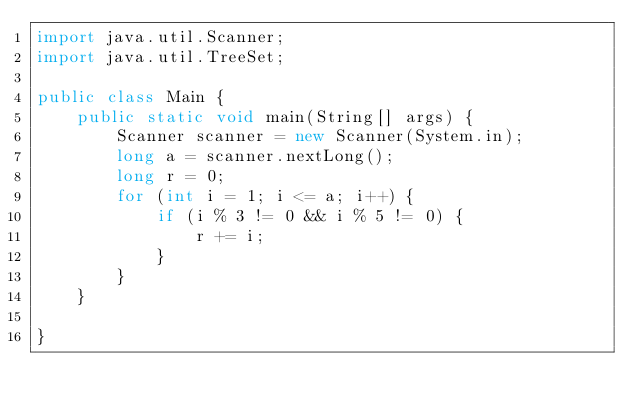<code> <loc_0><loc_0><loc_500><loc_500><_Java_>import java.util.Scanner;
import java.util.TreeSet;

public class Main {
    public static void main(String[] args) {
        Scanner scanner = new Scanner(System.in);
        long a = scanner.nextLong();
        long r = 0;
        for (int i = 1; i <= a; i++) {
            if (i % 3 != 0 && i % 5 != 0) {
                r += i;
            }
        }
    }

}</code> 